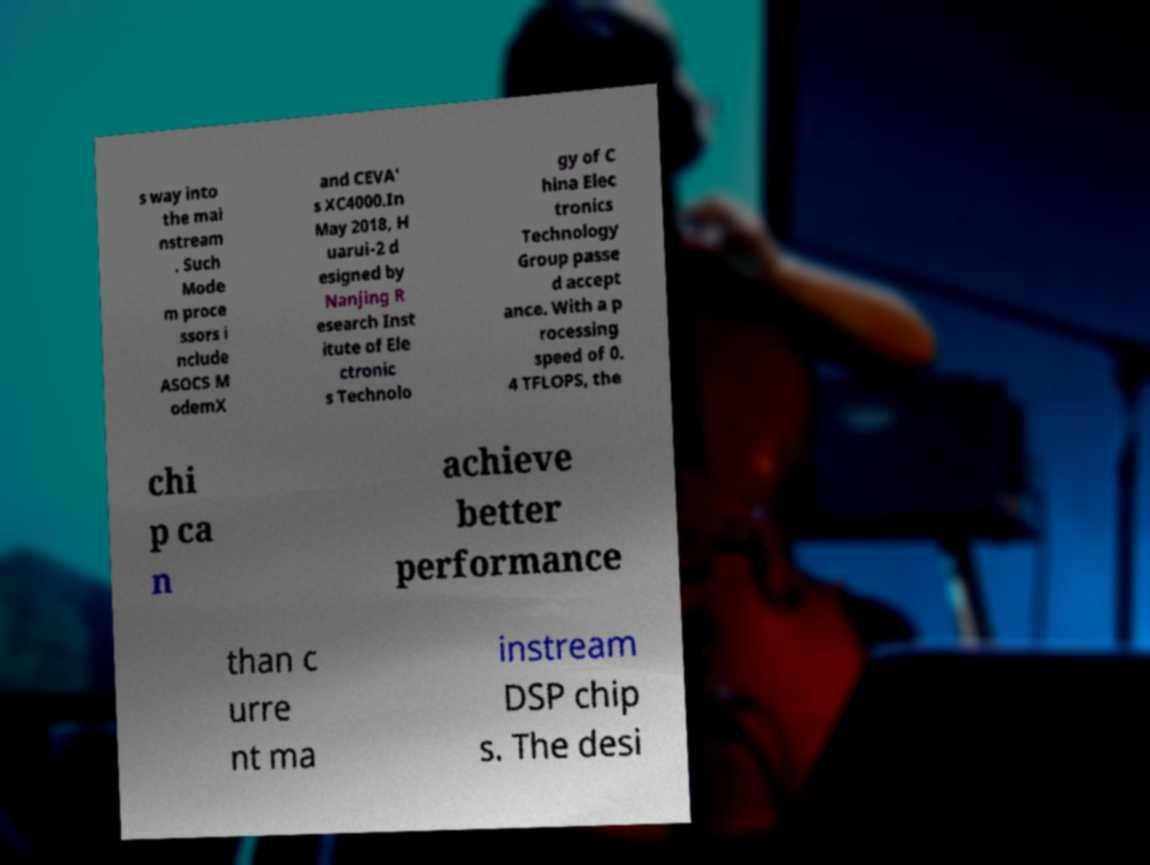Can you accurately transcribe the text from the provided image for me? s way into the mai nstream . Such Mode m proce ssors i nclude ASOCS M odemX and CEVA' s XC4000.In May 2018, H uarui-2 d esigned by Nanjing R esearch Inst itute of Ele ctronic s Technolo gy of C hina Elec tronics Technology Group passe d accept ance. With a p rocessing speed of 0. 4 TFLOPS, the chi p ca n achieve better performance than c urre nt ma instream DSP chip s. The desi 